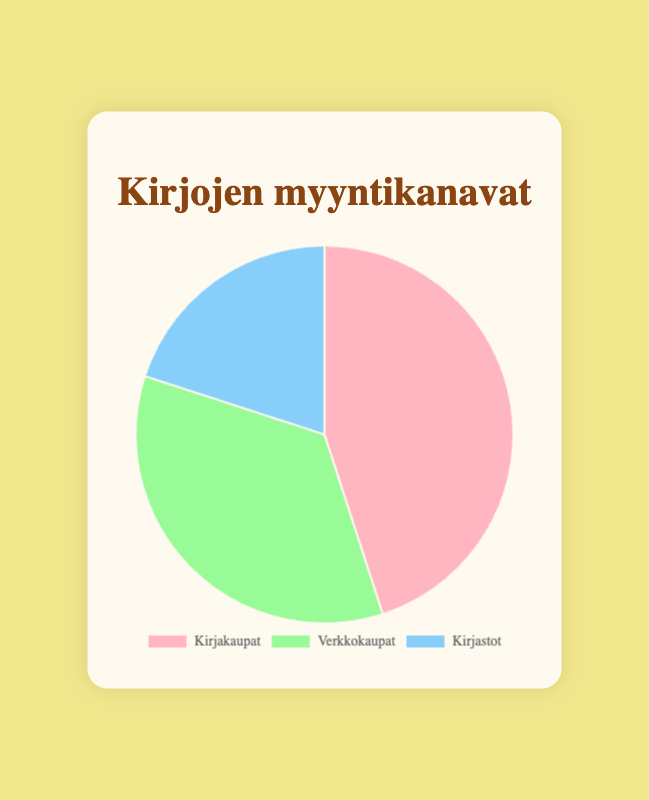Which sales channel has the highest sales percentage? The highest sales percentage can be identified by comparing the three given percentages. "Bookstores" with 45% has the highest sales percentage.
Answer: Bookstores Which sales channel has the lowest sales percentage? To find the lowest sales percentage, compare the three given percentages. "Libraries" with 20% has the lowest sales percentage.
Answer: Libraries What is the total percentage of sales from Online Marketplaces and Libraries combined? Add the percentages for "Online Marketplaces" and "Libraries": 35% + 20% = 55%.
Answer: 55% How much higher is the sales percentage through Bookstores compared to Libraries? Subtract the percentage of Libraries from Bookstores: 45% - 20% = 25%.
Answer: 25% What is the average percentage of sales across all three channels? Calculate the average by summing all percentages and dividing by the number of channels: (45% + 35% + 20%) / 3 = 100% / 3 ≈ 33.33%.
Answer: 33.33% Are the sales percentages for Bookstores and Online Marketplaces equal? Compare the percentages for Bookstores and Online Marketplaces: 45% is not equal to 35%.
Answer: No Which sales channel is represented by a pink color on the pie chart? The pie chart indicates that the pink segment corresponds to the first label. "Bookstores" is the first label.
Answer: Bookstores Which two sales channels together account for more than half of the total sales? Identify the combinations that exceed 50%: Bookstores and Online Marketplaces together account for 80% (45% + 35%).
Answer: Bookstores and Online Marketplaces 